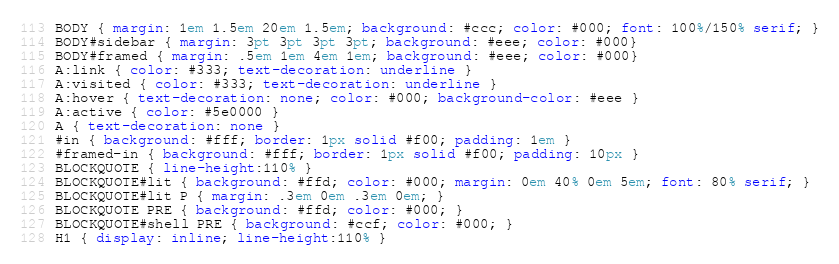Convert code to text. <code><loc_0><loc_0><loc_500><loc_500><_CSS_> BODY { margin: 1em 1.5em 20em 1.5em; background: #ccc; color: #000; font: 100%/150% serif; }
 BODY#sidebar { margin: 3pt 3pt 3pt 3pt; background: #eee; color: #000}
 BODY#framed { margin: .5em 1em 4em 1em; background: #eee; color: #000}
 A:link { color: #333; text-decoration: underline }
 A:visited { color: #333; text-decoration: underline }
 A:hover { text-decoration: none; color: #000; background-color: #eee }
 A:active { color: #5e0000 }
 A { text-decoration: none }
 #in { background: #fff; border: 1px solid #f00; padding: 1em }
 #framed-in { background: #fff; border: 1px solid #f00; padding: 10px }
 BLOCKQUOTE { line-height:110% }
 BLOCKQUOTE#lit { background: #ffd; color: #000; margin: 0em 40% 0em 5em; font: 80% serif; }
 BLOCKQUOTE#lit P { margin: .3em 0em .3em 0em; }
 BLOCKQUOTE PRE { background: #ffd; color: #000; }
 BLOCKQUOTE#shell PRE { background: #ccf; color: #000; }
 H1 { display: inline; line-height:110% }
</code> 